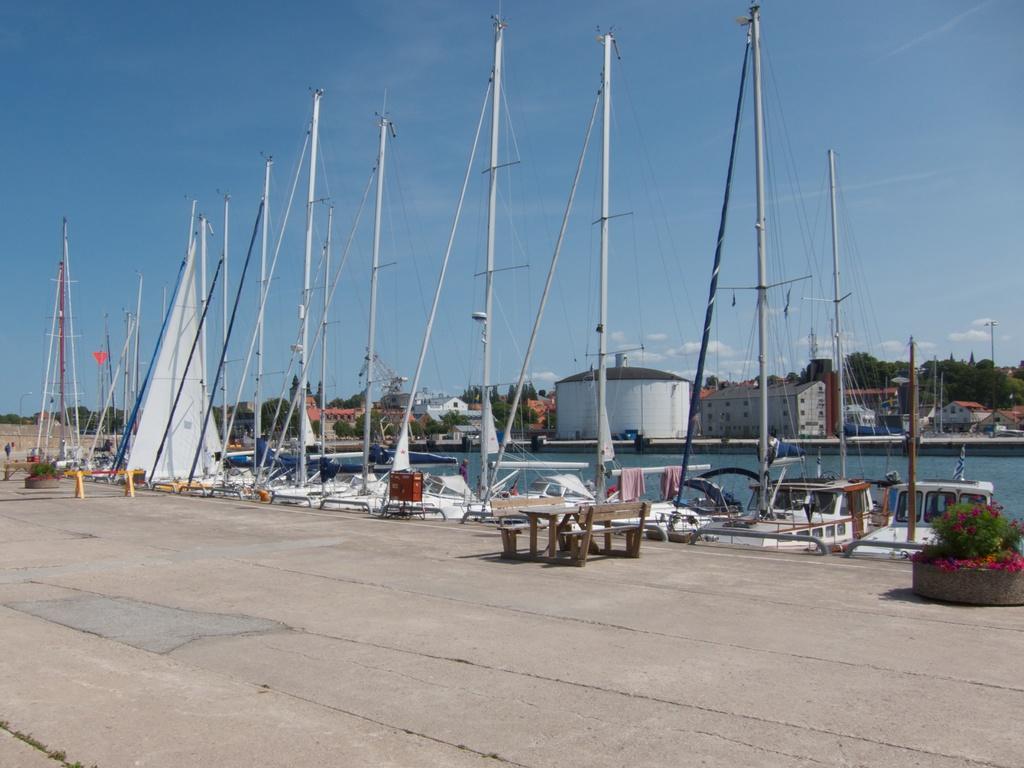In one or two sentences, can you explain what this image depicts? In this picture we can observe a fleet on the water. There is a table along with two benches on the dock. On the right side there are some flowers to the plants. In the background there are some buildings, trees and a sky. 